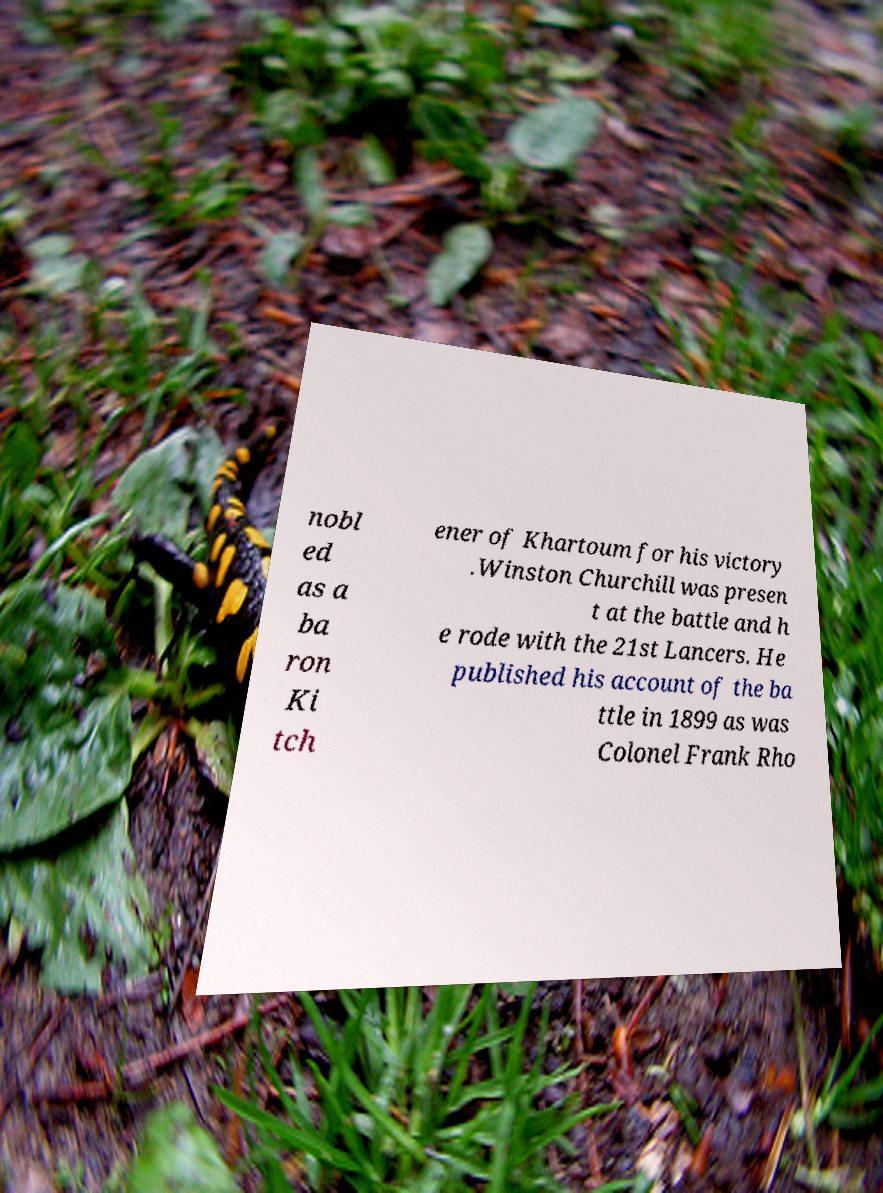What messages or text are displayed in this image? I need them in a readable, typed format. nobl ed as a ba ron Ki tch ener of Khartoum for his victory .Winston Churchill was presen t at the battle and h e rode with the 21st Lancers. He published his account of the ba ttle in 1899 as was Colonel Frank Rho 